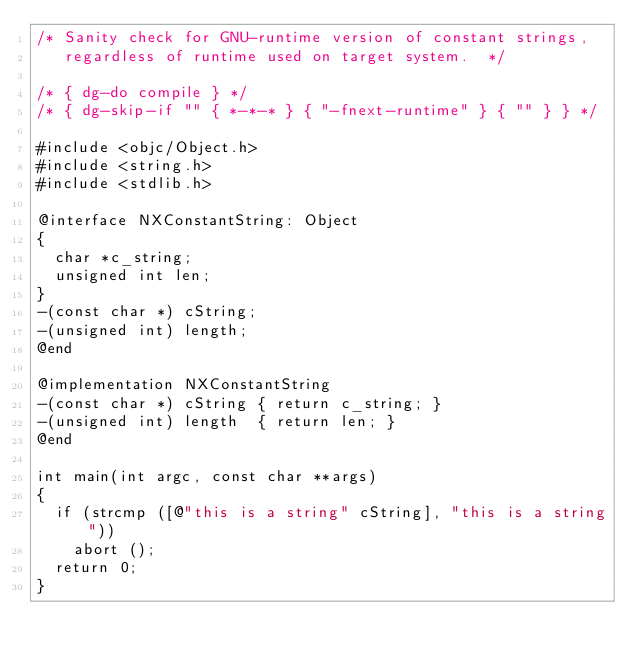<code> <loc_0><loc_0><loc_500><loc_500><_ObjectiveC_>/* Sanity check for GNU-runtime version of constant strings,
   regardless of runtime used on target system.  */

/* { dg-do compile } */
/* { dg-skip-if "" { *-*-* } { "-fnext-runtime" } { "" } } */

#include <objc/Object.h>
#include <string.h>
#include <stdlib.h>

@interface NXConstantString: Object
{
  char *c_string;
  unsigned int len;                                                     
}
-(const char *) cString;
-(unsigned int) length;
@end

@implementation NXConstantString
-(const char *) cString { return c_string; }
-(unsigned int) length  { return len; }
@end

int main(int argc, const char **args)
{
  if (strcmp ([@"this is a string" cString], "this is a string"))
    abort ();
  return 0;
}
</code> 